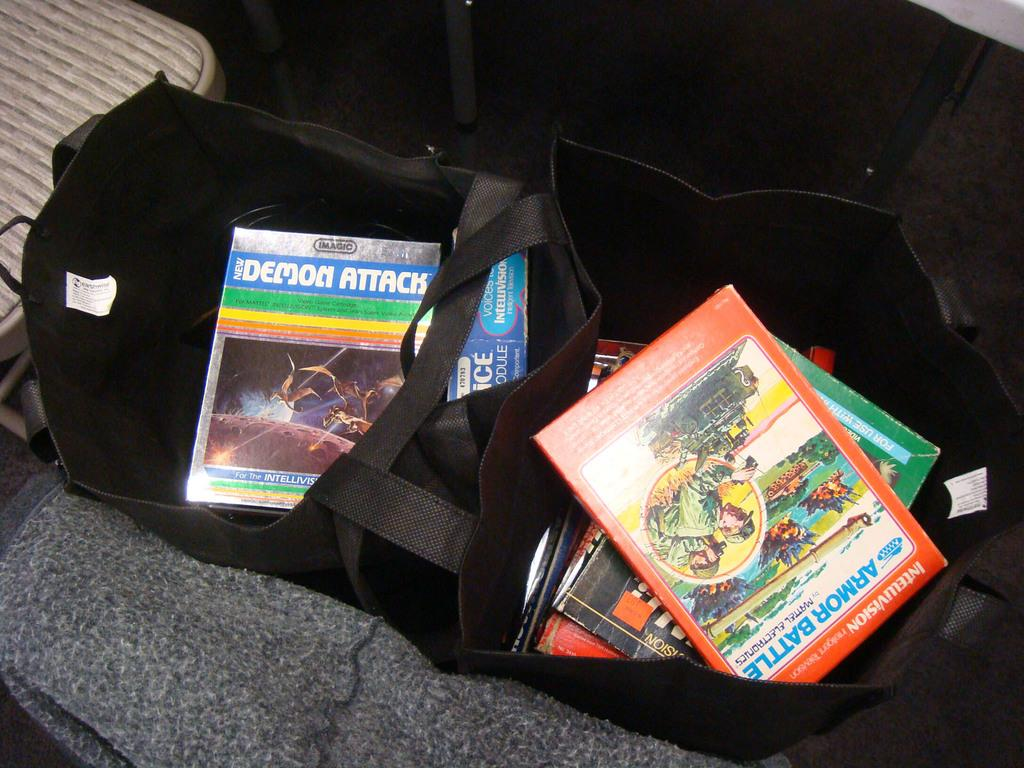Provide a one-sentence caption for the provided image. An open tote bag has a copy of the Demon Attack game in it. 